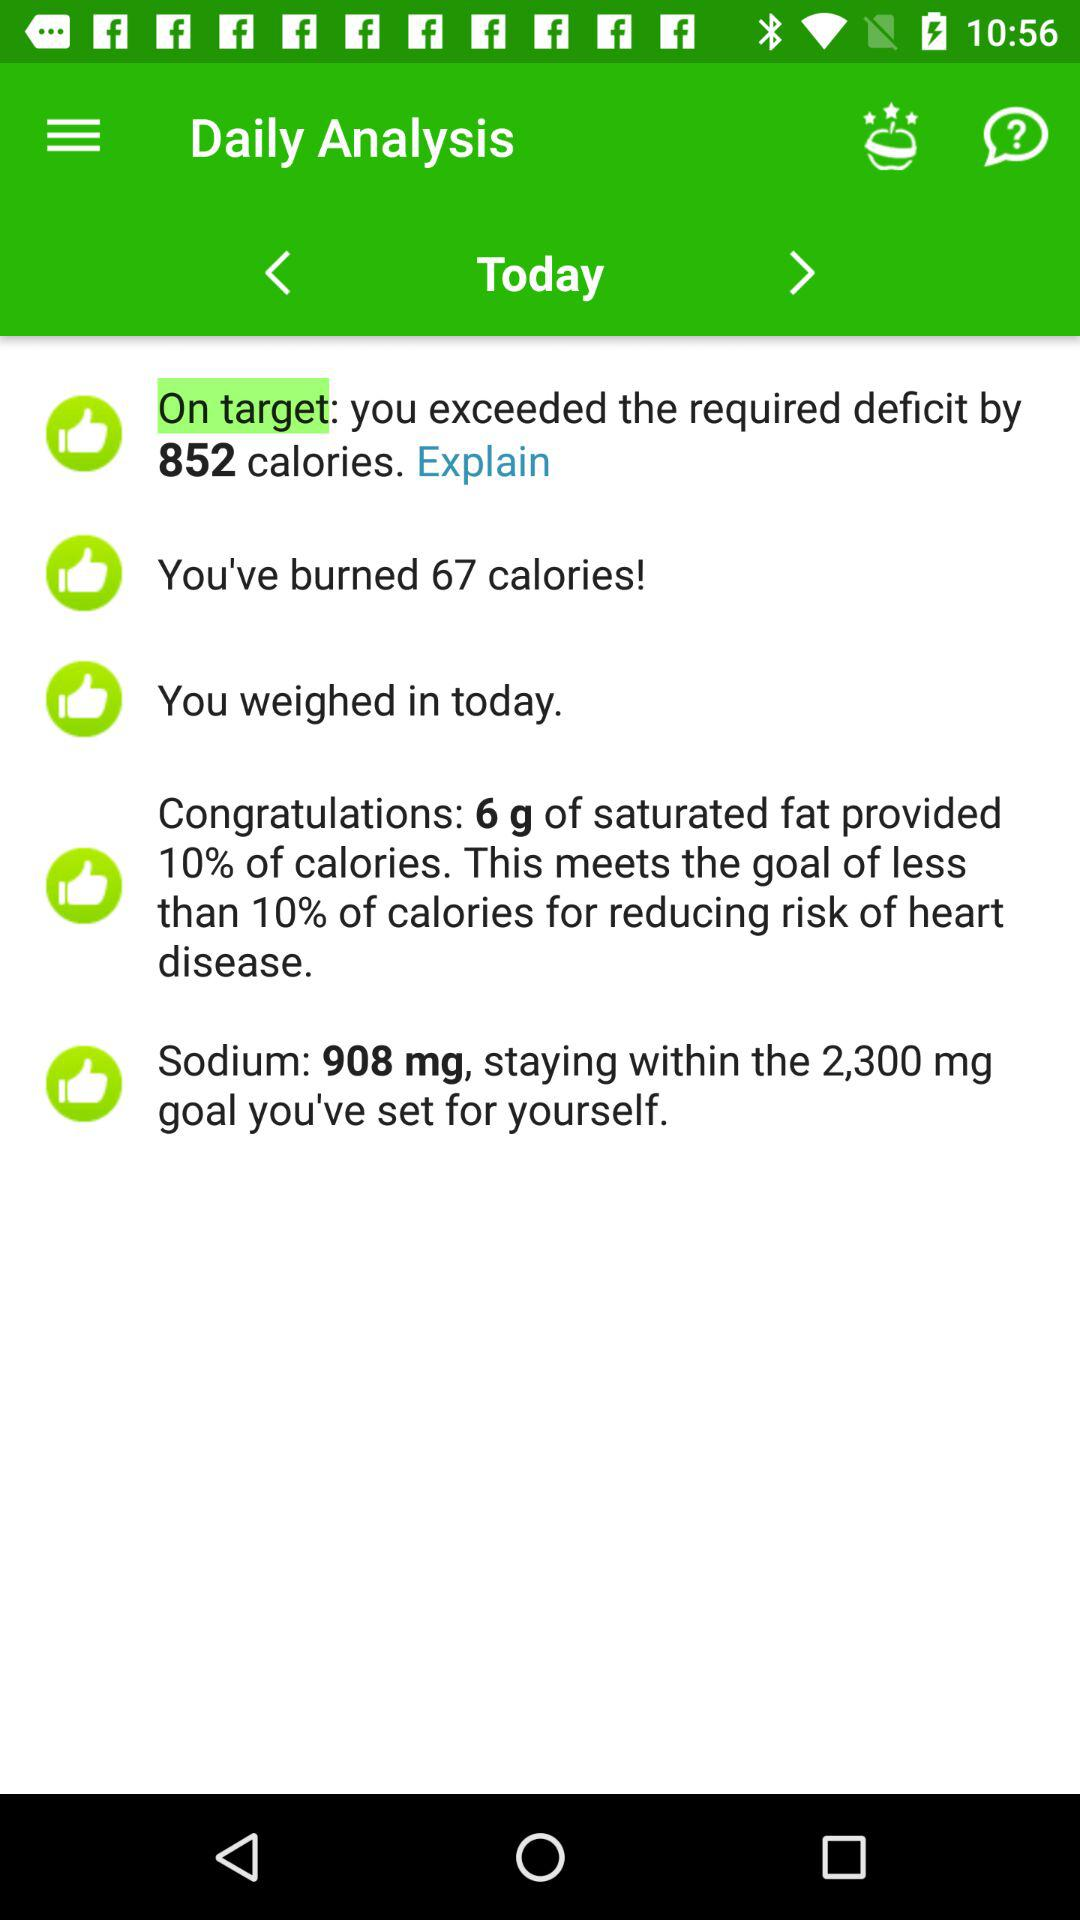How much sodium is staying within the goal? The amount of sodium staying within the goal is 908 milligrams. 